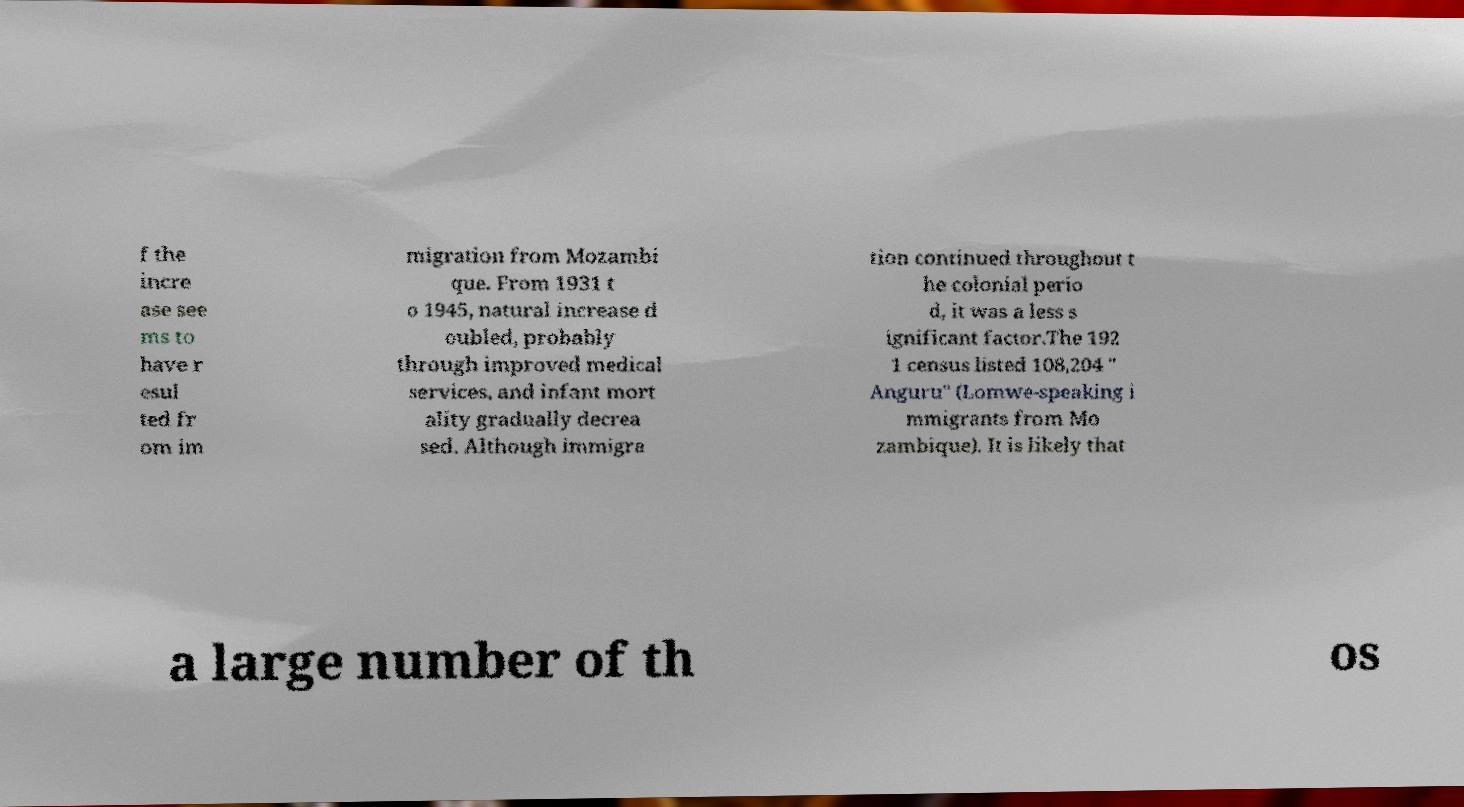Could you assist in decoding the text presented in this image and type it out clearly? f the incre ase see ms to have r esul ted fr om im migration from Mozambi que. From 1931 t o 1945, natural increase d oubled, probably through improved medical services, and infant mort ality gradually decrea sed. Although immigra tion continued throughout t he colonial perio d, it was a less s ignificant factor.The 192 1 census listed 108,204 " Anguru" (Lomwe-speaking i mmigrants from Mo zambique). It is likely that a large number of th os 